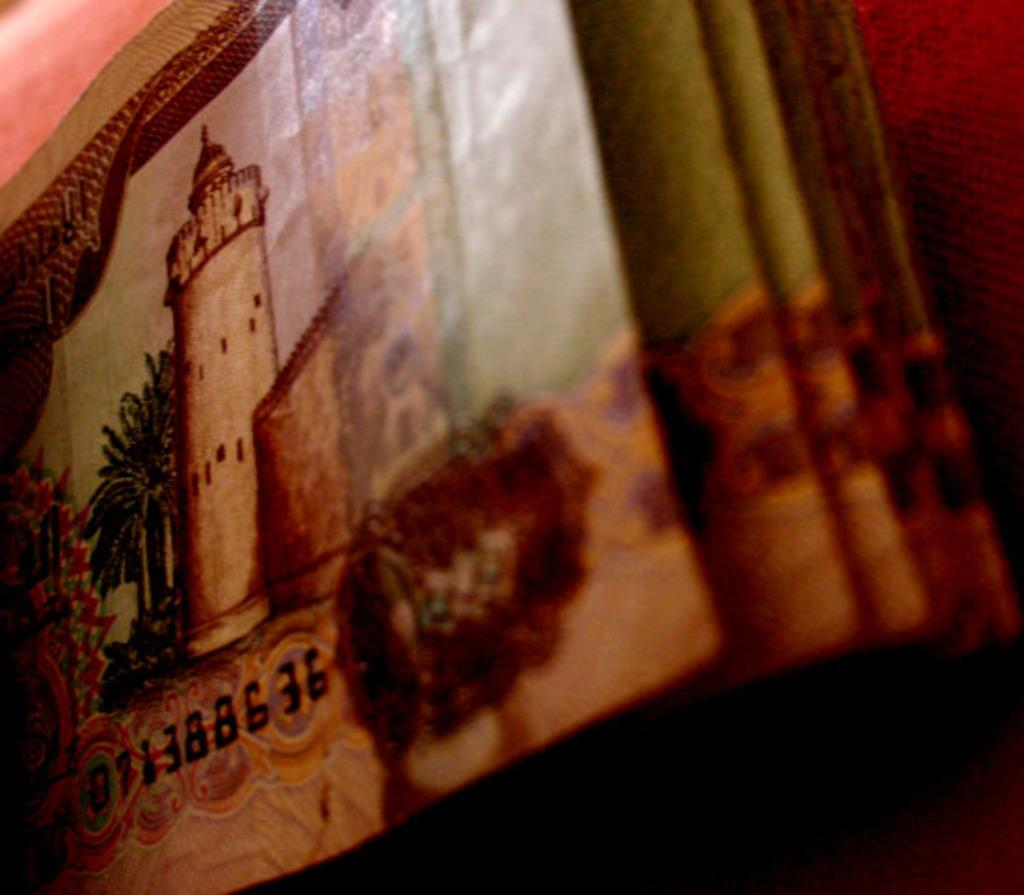Provide a one-sentence caption for the provided image. A stack of money has a bill with the serial number 071388636. 